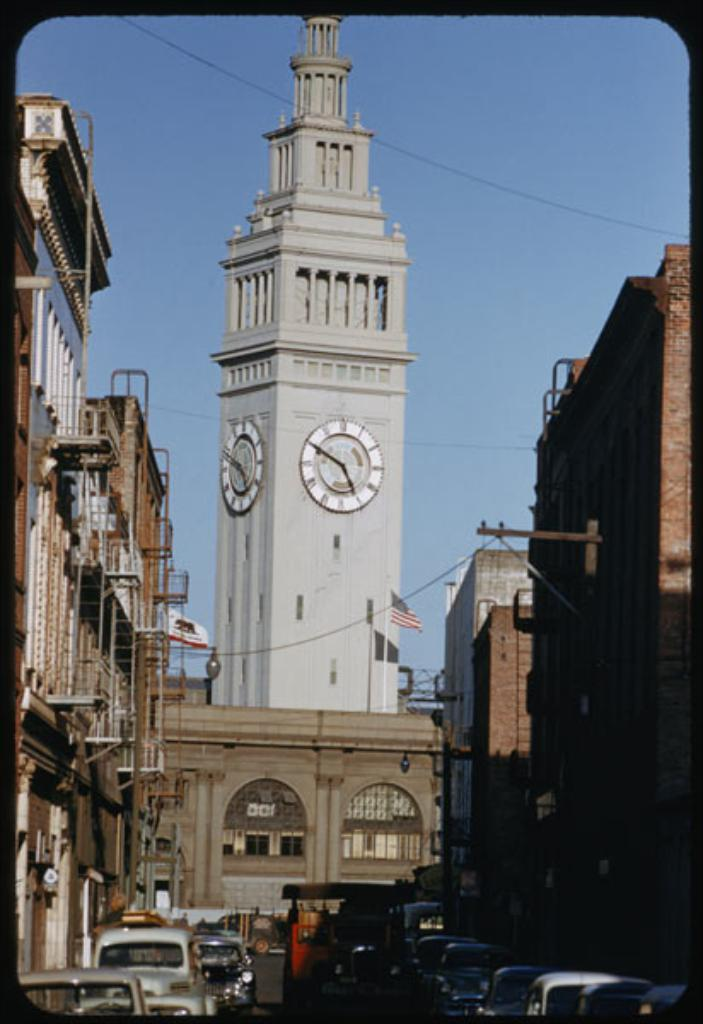What can be seen on the road in the image? There are vehicles on the road in the image. What type of structures are present in the image? There are buildings in the image. What additional elements can be seen in the image? There are flags in the image. What is visible in the background of the image? The sky is visible in the background of the image. Where is the bottle placed in the image? There is no bottle present in the image. What type of advertisement can be seen on the buildings in the image? There are no advertisements visible on the buildings in the image. 